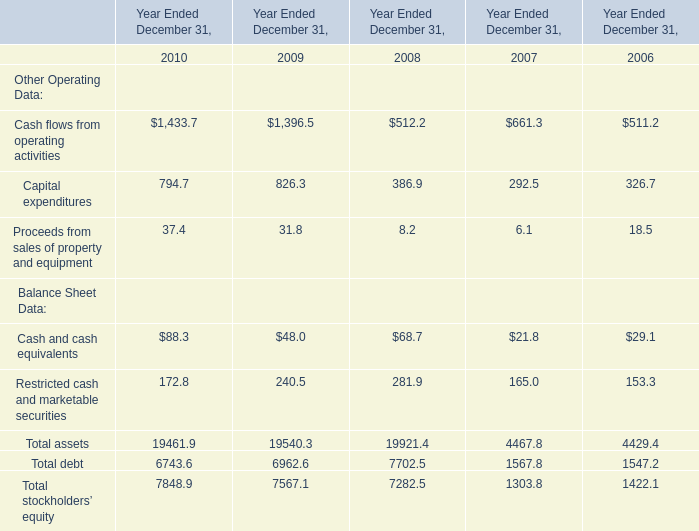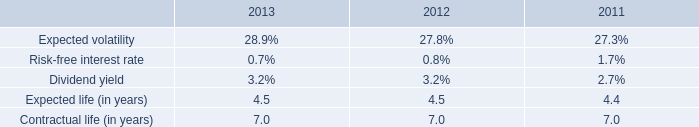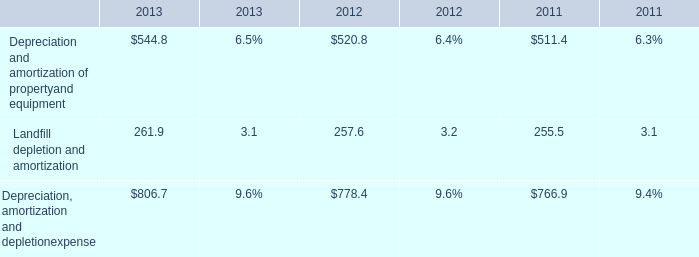The total amount of which section ranks first in 2010? 
Answer: Total assets. 